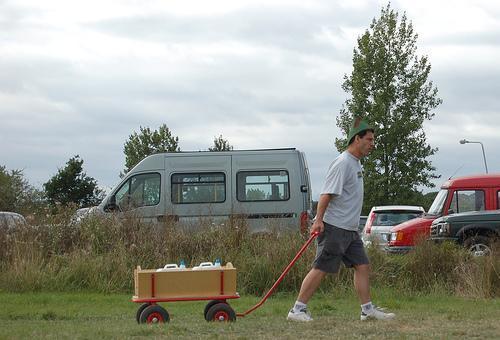How many people are pictured here?
Give a very brief answer. 1. 